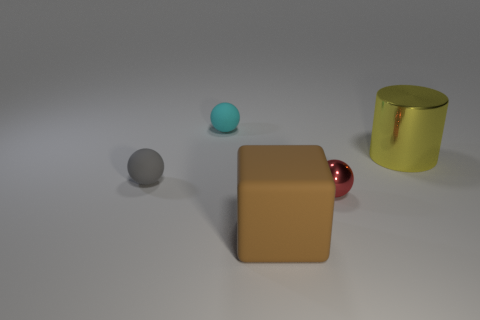What is the tiny metallic sphere made of, and how does it compare in appearance to the larger shiny object? The tiny metallic sphere seems to have a chrome finish, giving it a mirror-like appearance that reflects its surroundings. The larger shiny object, which appears golden, seems more like polished brass or gold due to its coloration and reflection quality. In essence, one is silver and highly reflective, whereas the other is gold and shiny but less reflective. 